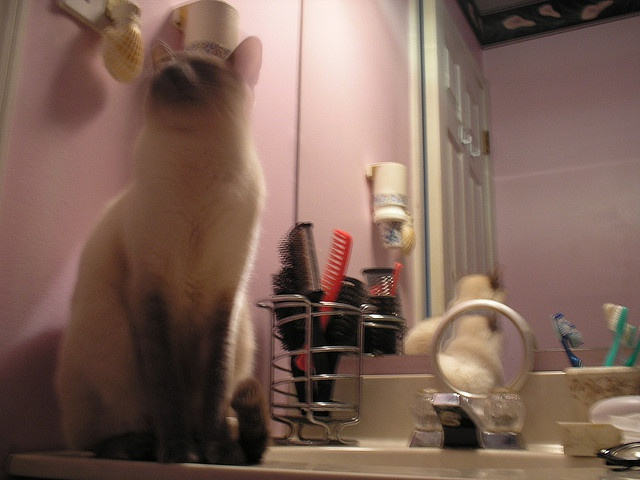Describe the objects in this image and their specific colors. I can see cat in gray, black, and maroon tones, sink in gray and tan tones, cat in gray and tan tones, toothbrush in gray, black, and navy tones, and toothbrush in gray, teal, and tan tones in this image. 